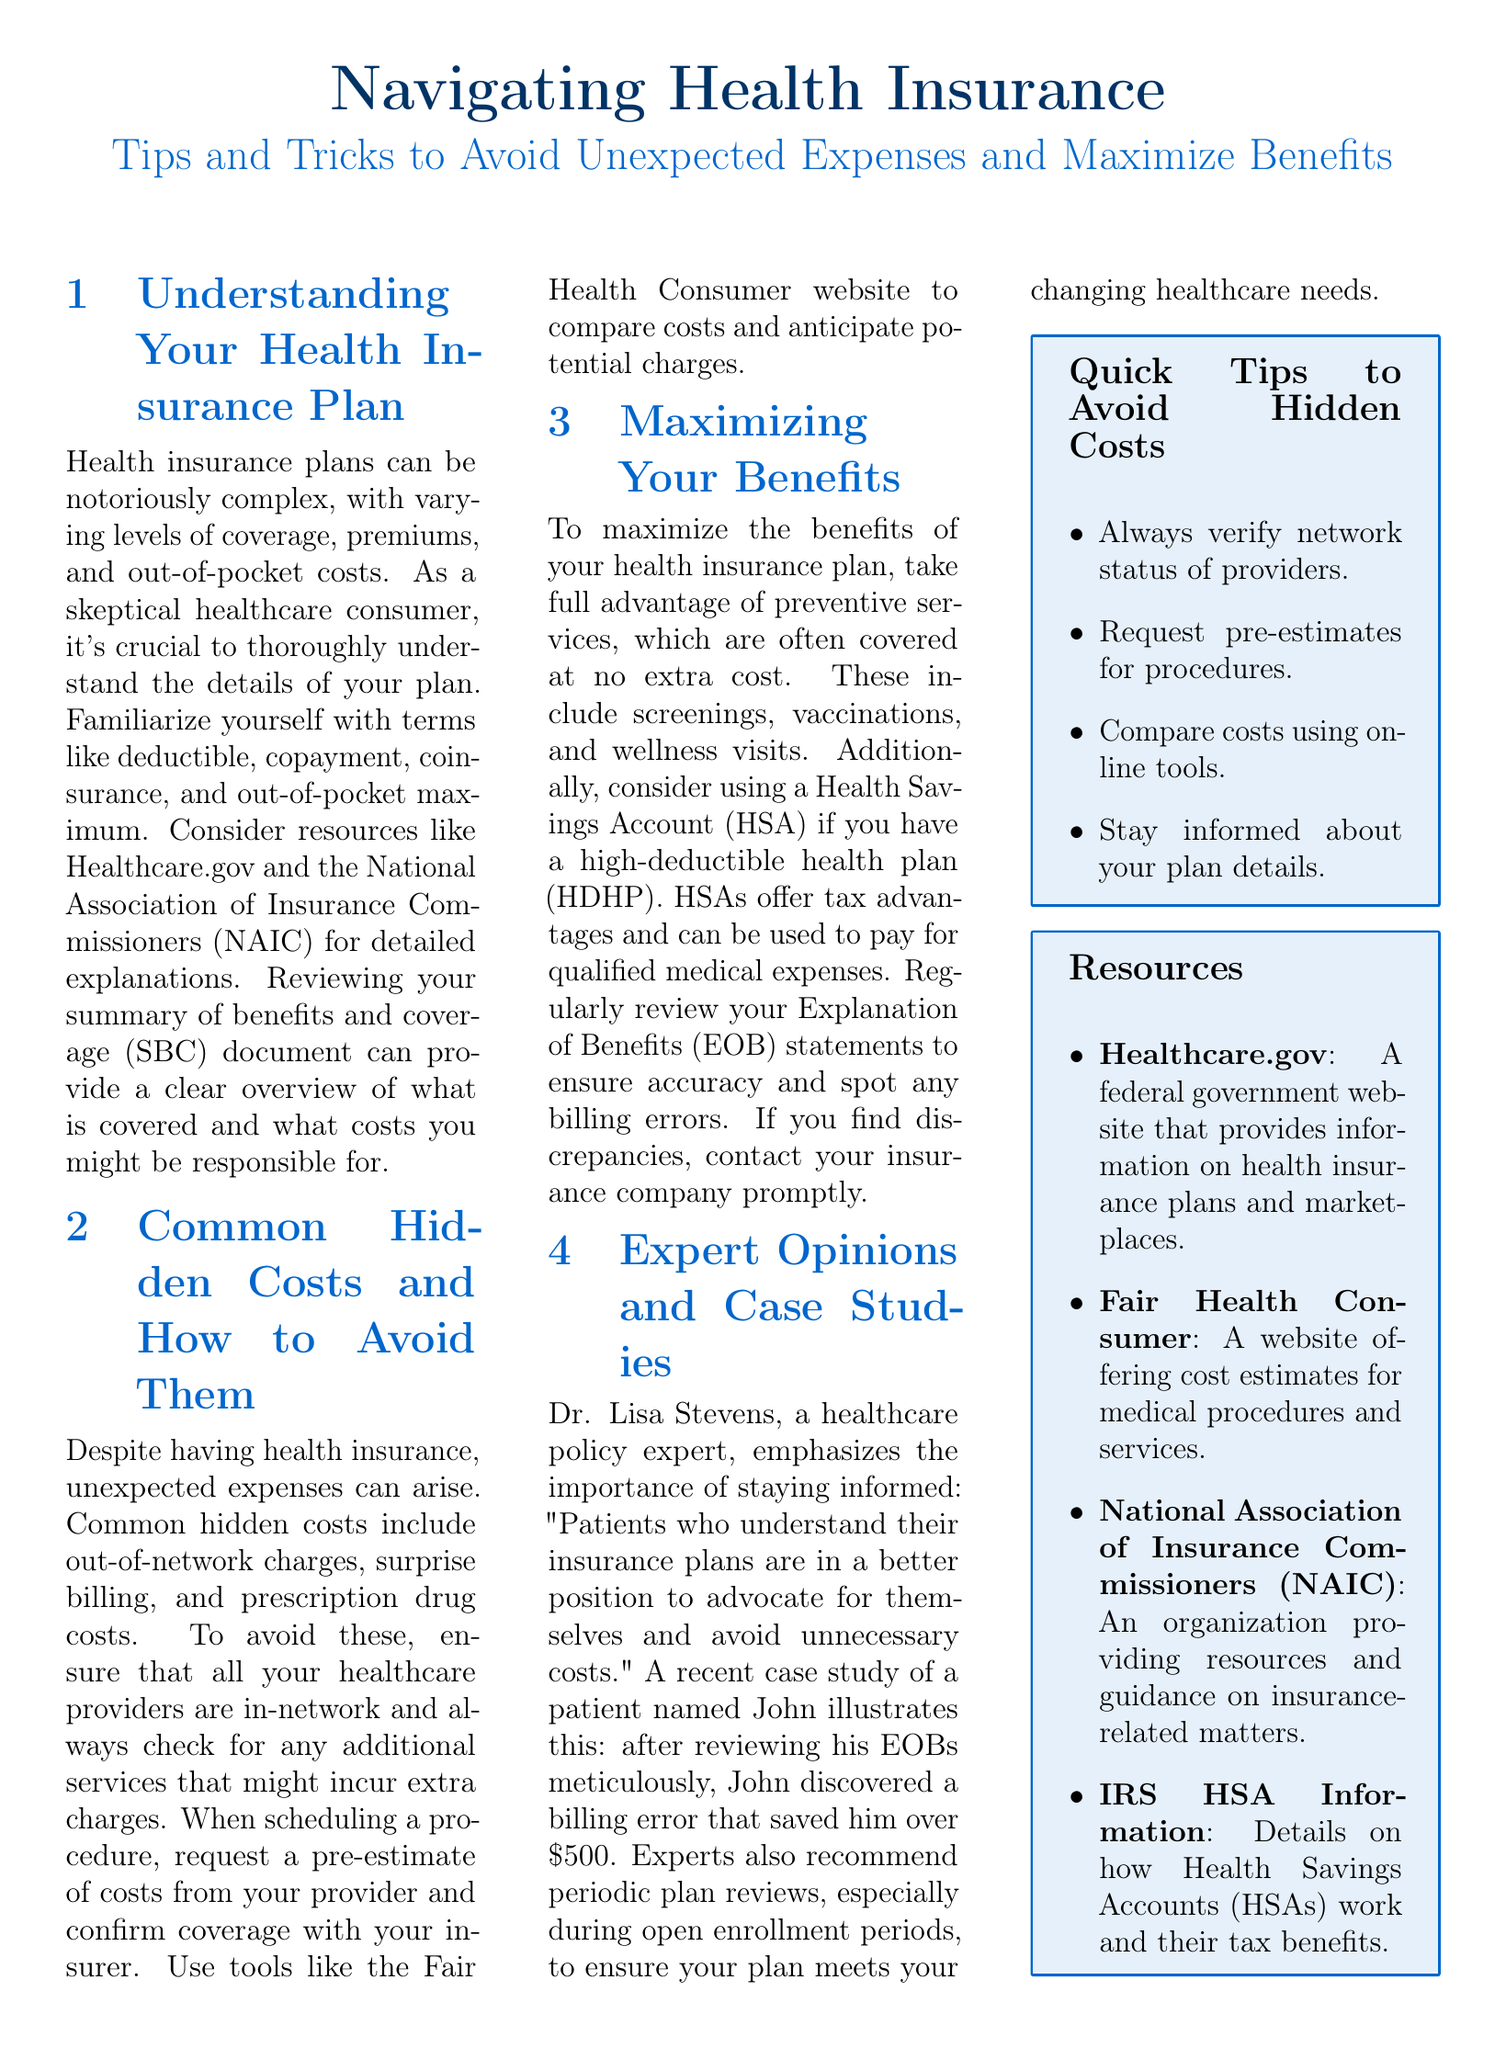What is the purpose of the document? The document aims to provide tips and tricks for navigating health insurance to avoid unexpected expenses and maximize benefits.
Answer: Tips and tricks for navigating health insurance What term describes the maximum amount a consumer will pay out of their own pocket? The document mentions this term as one of the key aspects of health insurance plans.
Answer: Out-of-pocket maximum Who emphasizes the importance of staying informed about health insurance? This individual is quoted in the document highlighting the need for patients to understand their insurance.
Answer: Dr. Lisa Stevens What type of account offers tax advantages for high-deductible health plans? The document discusses this specific account as beneficial for certain health insurance plans.
Answer: Health Savings Account How much could John save by discovering a billing error? This amount illustrates the potential savings emphasized in a case study within the document.
Answer: 500 dollars Which website provides cost estimates for medical procedures? The document lists this website as a resource for comparing medical costs.
Answer: Fair Health Consumer What should you request when scheduling a procedure to avoid unexpected costs? The document suggests this action to prevent surprise expenses associated with medical procedures.
Answer: Pre-estimate What document should you review to check for billing errors? The document advises regularly checking this document to ensure accuracy in billing.
Answer: Explanation of Benefits What organization provides resources on insurance-related matters? This organization is mentioned as a resource for understanding health insurance.
Answer: National Association of Insurance Commissioners 